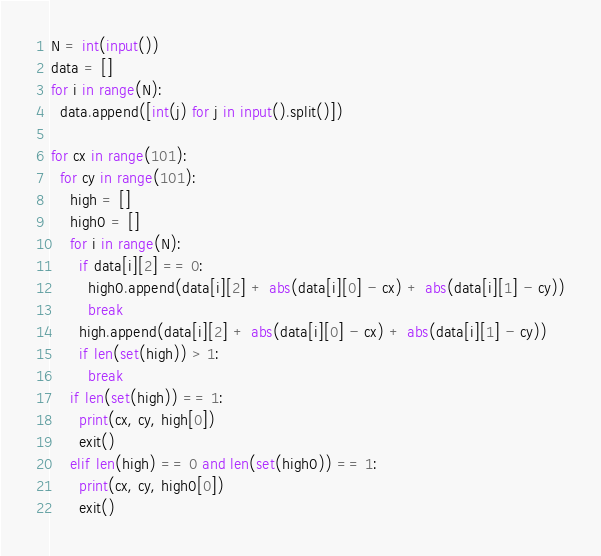<code> <loc_0><loc_0><loc_500><loc_500><_Python_>N = int(input())
data = []
for i in range(N):
  data.append([int(j) for j in input().split()])

for cx in range(101):
  for cy in range(101):
    high = []
    high0 = []
    for i in range(N):
      if data[i][2] == 0:
        high0.append(data[i][2] + abs(data[i][0] - cx) + abs(data[i][1] - cy))
        break
      high.append(data[i][2] + abs(data[i][0] - cx) + abs(data[i][1] - cy))
      if len(set(high)) > 1:
        break
    if len(set(high)) == 1:
      print(cx, cy, high[0])
      exit()
    elif len(high) == 0 and len(set(high0)) == 1:
      print(cx, cy, high0[0])
      exit()
</code> 